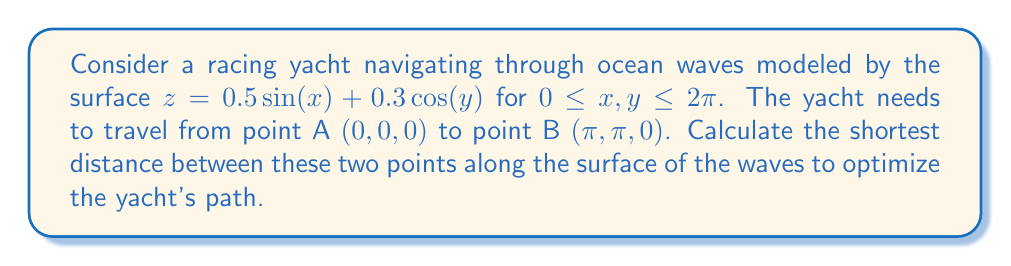Help me with this question. To find the shortest distance between two points on a curved surface, we need to use the concept of geodesics. For a general surface, this is a complex problem that often requires numerical methods. However, we can approximate the solution using the following steps:

1) First, we need to calculate the metric tensor of the surface. The metric tensor $g_{ij}$ is given by:

   $$g_{ij} = \begin{pmatrix}
   1 + (\frac{\partial z}{\partial x})^2 & \frac{\partial z}{\partial x}\frac{\partial z}{\partial y} \\
   \frac{\partial z}{\partial x}\frac{\partial z}{\partial y} & 1 + (\frac{\partial z}{\partial y})^2
   \end{pmatrix}$$

2) Calculate the partial derivatives:
   
   $\frac{\partial z}{\partial x} = 0.5\cos(x)$
   $\frac{\partial z}{\partial y} = -0.3\sin(y)$

3) Substitute these into the metric tensor:

   $$g_{ij} = \begin{pmatrix}
   1 + 0.25\cos^2(x) & -0.15\cos(x)\sin(y) \\
   -0.15\cos(x)\sin(y) & 1 + 0.09\sin^2(y)
   \end{pmatrix}$$

4) The geodesic equation involves solving a system of differential equations:

   $$\frac{d^2x^i}{ds^2} + \Gamma^i_{jk}\frac{dx^j}{ds}\frac{dx^k}{ds} = 0$$

   where $\Gamma^i_{jk}$ are the Christoffel symbols.

5) Solving this system of equations analytically is extremely complex for this surface. Instead, we can use a numerical method like the shooting method or gradient descent to find the geodesic.

6) As an approximation, we can calculate the arc length of the straight line path between A and B on the surface:

   $$L = \int_0^1 \sqrt{(\frac{dx}{dt})^2 + (\frac{dy}{dt})^2 + (\frac{dz}{dt})^2} dt$$

   where $x(t) = \pi t$, $y(t) = \pi t$, and $z(t) = 0.5\sin(\pi t) + 0.3\cos(\pi t)$ for $0 \leq t \leq 1$.

7) This integral can be evaluated numerically using methods like Simpson's rule or Gaussian quadrature.

8) Using a numerical integration method, we find that the approximate arc length is about 4.54 units.

Note: This is an approximation and the actual geodesic distance would be slightly shorter than this arc length.
Answer: $\approx 4.54$ units 